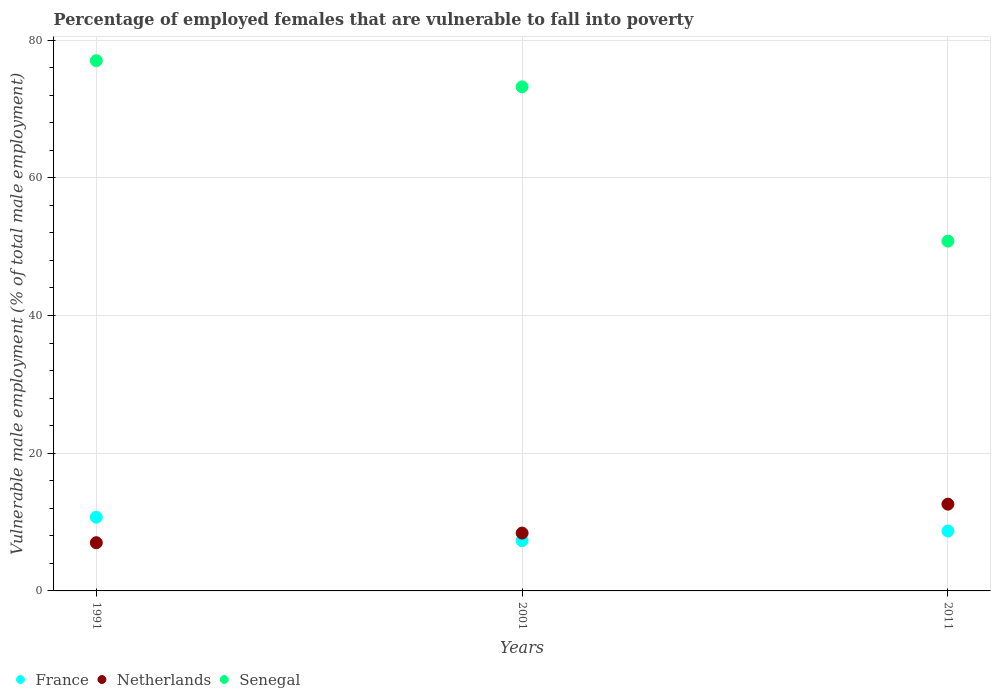How many different coloured dotlines are there?
Provide a short and direct response. 3. Is the number of dotlines equal to the number of legend labels?
Your response must be concise. Yes. What is the percentage of employed females who are vulnerable to fall into poverty in Senegal in 2011?
Offer a very short reply. 50.8. Across all years, what is the maximum percentage of employed females who are vulnerable to fall into poverty in Netherlands?
Offer a terse response. 12.6. Across all years, what is the minimum percentage of employed females who are vulnerable to fall into poverty in France?
Offer a very short reply. 7.3. What is the total percentage of employed females who are vulnerable to fall into poverty in Senegal in the graph?
Provide a succinct answer. 201. What is the difference between the percentage of employed females who are vulnerable to fall into poverty in Netherlands in 1991 and that in 2001?
Your answer should be very brief. -1.4. What is the difference between the percentage of employed females who are vulnerable to fall into poverty in France in 1991 and the percentage of employed females who are vulnerable to fall into poverty in Netherlands in 2001?
Your answer should be compact. 2.3. What is the average percentage of employed females who are vulnerable to fall into poverty in France per year?
Keep it short and to the point. 8.9. In the year 1991, what is the difference between the percentage of employed females who are vulnerable to fall into poverty in France and percentage of employed females who are vulnerable to fall into poverty in Senegal?
Offer a very short reply. -66.3. What is the ratio of the percentage of employed females who are vulnerable to fall into poverty in Senegal in 2001 to that in 2011?
Provide a succinct answer. 1.44. Is the percentage of employed females who are vulnerable to fall into poverty in Netherlands in 1991 less than that in 2001?
Offer a terse response. Yes. What is the difference between the highest and the second highest percentage of employed females who are vulnerable to fall into poverty in Netherlands?
Your response must be concise. 4.2. What is the difference between the highest and the lowest percentage of employed females who are vulnerable to fall into poverty in Netherlands?
Your response must be concise. 5.6. In how many years, is the percentage of employed females who are vulnerable to fall into poverty in France greater than the average percentage of employed females who are vulnerable to fall into poverty in France taken over all years?
Make the answer very short. 1. Is the sum of the percentage of employed females who are vulnerable to fall into poverty in Netherlands in 1991 and 2011 greater than the maximum percentage of employed females who are vulnerable to fall into poverty in France across all years?
Your answer should be very brief. Yes. Is it the case that in every year, the sum of the percentage of employed females who are vulnerable to fall into poverty in France and percentage of employed females who are vulnerable to fall into poverty in Netherlands  is greater than the percentage of employed females who are vulnerable to fall into poverty in Senegal?
Provide a short and direct response. No. Does the percentage of employed females who are vulnerable to fall into poverty in Netherlands monotonically increase over the years?
Offer a very short reply. Yes. How many years are there in the graph?
Keep it short and to the point. 3. What is the difference between two consecutive major ticks on the Y-axis?
Your response must be concise. 20. Does the graph contain grids?
Ensure brevity in your answer.  Yes. How many legend labels are there?
Ensure brevity in your answer.  3. What is the title of the graph?
Provide a succinct answer. Percentage of employed females that are vulnerable to fall into poverty. What is the label or title of the X-axis?
Give a very brief answer. Years. What is the label or title of the Y-axis?
Your answer should be very brief. Vulnerable male employment (% of total male employment). What is the Vulnerable male employment (% of total male employment) of France in 1991?
Your answer should be very brief. 10.7. What is the Vulnerable male employment (% of total male employment) of Netherlands in 1991?
Offer a very short reply. 7. What is the Vulnerable male employment (% of total male employment) of Senegal in 1991?
Your answer should be compact. 77. What is the Vulnerable male employment (% of total male employment) of France in 2001?
Provide a succinct answer. 7.3. What is the Vulnerable male employment (% of total male employment) in Netherlands in 2001?
Your answer should be very brief. 8.4. What is the Vulnerable male employment (% of total male employment) in Senegal in 2001?
Offer a terse response. 73.2. What is the Vulnerable male employment (% of total male employment) of France in 2011?
Ensure brevity in your answer.  8.7. What is the Vulnerable male employment (% of total male employment) of Netherlands in 2011?
Keep it short and to the point. 12.6. What is the Vulnerable male employment (% of total male employment) in Senegal in 2011?
Offer a terse response. 50.8. Across all years, what is the maximum Vulnerable male employment (% of total male employment) of France?
Ensure brevity in your answer.  10.7. Across all years, what is the maximum Vulnerable male employment (% of total male employment) in Netherlands?
Provide a short and direct response. 12.6. Across all years, what is the minimum Vulnerable male employment (% of total male employment) of France?
Provide a short and direct response. 7.3. Across all years, what is the minimum Vulnerable male employment (% of total male employment) in Netherlands?
Your answer should be compact. 7. Across all years, what is the minimum Vulnerable male employment (% of total male employment) of Senegal?
Ensure brevity in your answer.  50.8. What is the total Vulnerable male employment (% of total male employment) of France in the graph?
Your response must be concise. 26.7. What is the total Vulnerable male employment (% of total male employment) in Senegal in the graph?
Provide a short and direct response. 201. What is the difference between the Vulnerable male employment (% of total male employment) in Senegal in 1991 and that in 2001?
Offer a very short reply. 3.8. What is the difference between the Vulnerable male employment (% of total male employment) of Netherlands in 1991 and that in 2011?
Provide a short and direct response. -5.6. What is the difference between the Vulnerable male employment (% of total male employment) in Senegal in 1991 and that in 2011?
Offer a terse response. 26.2. What is the difference between the Vulnerable male employment (% of total male employment) of Netherlands in 2001 and that in 2011?
Provide a short and direct response. -4.2. What is the difference between the Vulnerable male employment (% of total male employment) of Senegal in 2001 and that in 2011?
Your answer should be very brief. 22.4. What is the difference between the Vulnerable male employment (% of total male employment) in France in 1991 and the Vulnerable male employment (% of total male employment) in Netherlands in 2001?
Your answer should be very brief. 2.3. What is the difference between the Vulnerable male employment (% of total male employment) in France in 1991 and the Vulnerable male employment (% of total male employment) in Senegal in 2001?
Offer a terse response. -62.5. What is the difference between the Vulnerable male employment (% of total male employment) of Netherlands in 1991 and the Vulnerable male employment (% of total male employment) of Senegal in 2001?
Your answer should be compact. -66.2. What is the difference between the Vulnerable male employment (% of total male employment) of France in 1991 and the Vulnerable male employment (% of total male employment) of Senegal in 2011?
Provide a short and direct response. -40.1. What is the difference between the Vulnerable male employment (% of total male employment) of Netherlands in 1991 and the Vulnerable male employment (% of total male employment) of Senegal in 2011?
Keep it short and to the point. -43.8. What is the difference between the Vulnerable male employment (% of total male employment) in France in 2001 and the Vulnerable male employment (% of total male employment) in Senegal in 2011?
Make the answer very short. -43.5. What is the difference between the Vulnerable male employment (% of total male employment) in Netherlands in 2001 and the Vulnerable male employment (% of total male employment) in Senegal in 2011?
Provide a succinct answer. -42.4. What is the average Vulnerable male employment (% of total male employment) in Netherlands per year?
Keep it short and to the point. 9.33. What is the average Vulnerable male employment (% of total male employment) in Senegal per year?
Make the answer very short. 67. In the year 1991, what is the difference between the Vulnerable male employment (% of total male employment) in France and Vulnerable male employment (% of total male employment) in Senegal?
Provide a succinct answer. -66.3. In the year 1991, what is the difference between the Vulnerable male employment (% of total male employment) in Netherlands and Vulnerable male employment (% of total male employment) in Senegal?
Offer a very short reply. -70. In the year 2001, what is the difference between the Vulnerable male employment (% of total male employment) in France and Vulnerable male employment (% of total male employment) in Senegal?
Provide a short and direct response. -65.9. In the year 2001, what is the difference between the Vulnerable male employment (% of total male employment) of Netherlands and Vulnerable male employment (% of total male employment) of Senegal?
Your answer should be very brief. -64.8. In the year 2011, what is the difference between the Vulnerable male employment (% of total male employment) of France and Vulnerable male employment (% of total male employment) of Netherlands?
Your response must be concise. -3.9. In the year 2011, what is the difference between the Vulnerable male employment (% of total male employment) of France and Vulnerable male employment (% of total male employment) of Senegal?
Give a very brief answer. -42.1. In the year 2011, what is the difference between the Vulnerable male employment (% of total male employment) in Netherlands and Vulnerable male employment (% of total male employment) in Senegal?
Ensure brevity in your answer.  -38.2. What is the ratio of the Vulnerable male employment (% of total male employment) in France in 1991 to that in 2001?
Provide a short and direct response. 1.47. What is the ratio of the Vulnerable male employment (% of total male employment) in Netherlands in 1991 to that in 2001?
Your response must be concise. 0.83. What is the ratio of the Vulnerable male employment (% of total male employment) in Senegal in 1991 to that in 2001?
Give a very brief answer. 1.05. What is the ratio of the Vulnerable male employment (% of total male employment) in France in 1991 to that in 2011?
Give a very brief answer. 1.23. What is the ratio of the Vulnerable male employment (% of total male employment) in Netherlands in 1991 to that in 2011?
Keep it short and to the point. 0.56. What is the ratio of the Vulnerable male employment (% of total male employment) of Senegal in 1991 to that in 2011?
Provide a short and direct response. 1.52. What is the ratio of the Vulnerable male employment (% of total male employment) of France in 2001 to that in 2011?
Offer a very short reply. 0.84. What is the ratio of the Vulnerable male employment (% of total male employment) in Netherlands in 2001 to that in 2011?
Ensure brevity in your answer.  0.67. What is the ratio of the Vulnerable male employment (% of total male employment) in Senegal in 2001 to that in 2011?
Your answer should be very brief. 1.44. What is the difference between the highest and the second highest Vulnerable male employment (% of total male employment) in Netherlands?
Your response must be concise. 4.2. What is the difference between the highest and the second highest Vulnerable male employment (% of total male employment) of Senegal?
Your response must be concise. 3.8. What is the difference between the highest and the lowest Vulnerable male employment (% of total male employment) of France?
Ensure brevity in your answer.  3.4. What is the difference between the highest and the lowest Vulnerable male employment (% of total male employment) in Netherlands?
Your response must be concise. 5.6. What is the difference between the highest and the lowest Vulnerable male employment (% of total male employment) in Senegal?
Give a very brief answer. 26.2. 